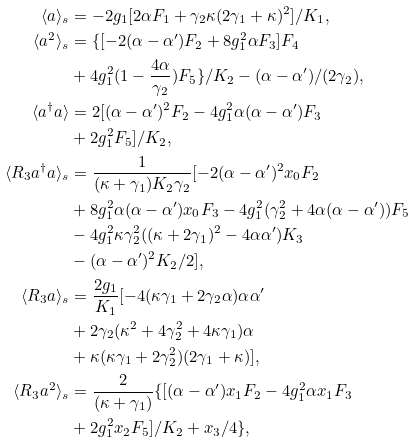Convert formula to latex. <formula><loc_0><loc_0><loc_500><loc_500>\langle { a } \rangle _ { s } & = - 2 g _ { 1 } [ 2 \alpha { F _ { 1 } } + \gamma _ { 2 } \kappa ( 2 \gamma _ { 1 } + \kappa ) ^ { 2 } ] / K _ { 1 } , \\ \langle { a ^ { 2 } } \rangle _ { s } & = \{ [ - 2 ( \alpha - \alpha ^ { \prime } ) F _ { 2 } + 8 g _ { 1 } ^ { 2 } \alpha { F _ { 3 } } ] F _ { 4 } \\ & + 4 g _ { 1 } ^ { 2 } ( 1 - \frac { 4 \alpha } { \gamma _ { 2 } } ) F _ { 5 } \} / K _ { 2 } - ( \alpha - \alpha ^ { \prime } ) / ( 2 \gamma _ { 2 } ) , \\ \langle { a ^ { \dag } a } \rangle & = 2 [ ( \alpha - \alpha ^ { \prime } ) ^ { 2 } F _ { 2 } - 4 g _ { 1 } ^ { 2 } \alpha ( \alpha - \alpha ^ { \prime } ) F _ { 3 } \\ & + 2 g _ { 1 } ^ { 2 } F _ { 5 } ] / K _ { 2 } , \\ \langle { R _ { 3 } a ^ { \dag } a } \rangle _ { s } & = \frac { 1 } { ( \kappa + \gamma _ { 1 } ) K _ { 2 } \gamma _ { 2 } } [ - 2 ( \alpha - \alpha ^ { \prime } ) ^ { 2 } x _ { 0 } F _ { 2 } \\ & + 8 g _ { 1 } ^ { 2 } \alpha ( \alpha - \alpha ^ { \prime } ) x _ { 0 } F _ { 3 } - 4 g _ { 1 } ^ { 2 } ( \gamma _ { 2 } ^ { 2 } + 4 \alpha ( \alpha - \alpha ^ { \prime } ) ) F _ { 5 } \\ & - 4 g _ { 1 } ^ { 2 } \kappa \gamma _ { 2 } ^ { 2 } ( ( \kappa + 2 \gamma _ { 1 } ) ^ { 2 } - 4 \alpha \alpha ^ { \prime } ) K _ { 3 } \\ & - ( \alpha - \alpha ^ { \prime } ) ^ { 2 } K _ { 2 } / 2 ] , \\ \langle { R _ { 3 } a } \rangle _ { s } & = \frac { 2 g _ { 1 } } { K _ { 1 } } [ - 4 ( \kappa \gamma _ { 1 } + 2 \gamma _ { 2 } \alpha ) \alpha \alpha ^ { \prime } \\ & + 2 \gamma _ { 2 } ( \kappa ^ { 2 } + 4 \gamma _ { 2 } ^ { 2 } + 4 \kappa \gamma _ { 1 } ) \alpha \\ & + \kappa ( \kappa \gamma _ { 1 } + 2 \gamma _ { 2 } ^ { 2 } ) ( 2 \gamma _ { 1 } + \kappa ) ] , \\ \langle { R _ { 3 } a ^ { 2 } } \rangle _ { s } & = \frac { 2 } { ( \kappa + \gamma _ { 1 } ) } \{ [ ( \alpha - \alpha ^ { \prime } ) x _ { 1 } F _ { 2 } - 4 g _ { 1 } ^ { 2 } \alpha { x _ { 1 } } F _ { 3 } \\ & + 2 g _ { 1 } ^ { 2 } x _ { 2 } F _ { 5 } ] / K _ { 2 } + x _ { 3 } / 4 \} , \\</formula> 